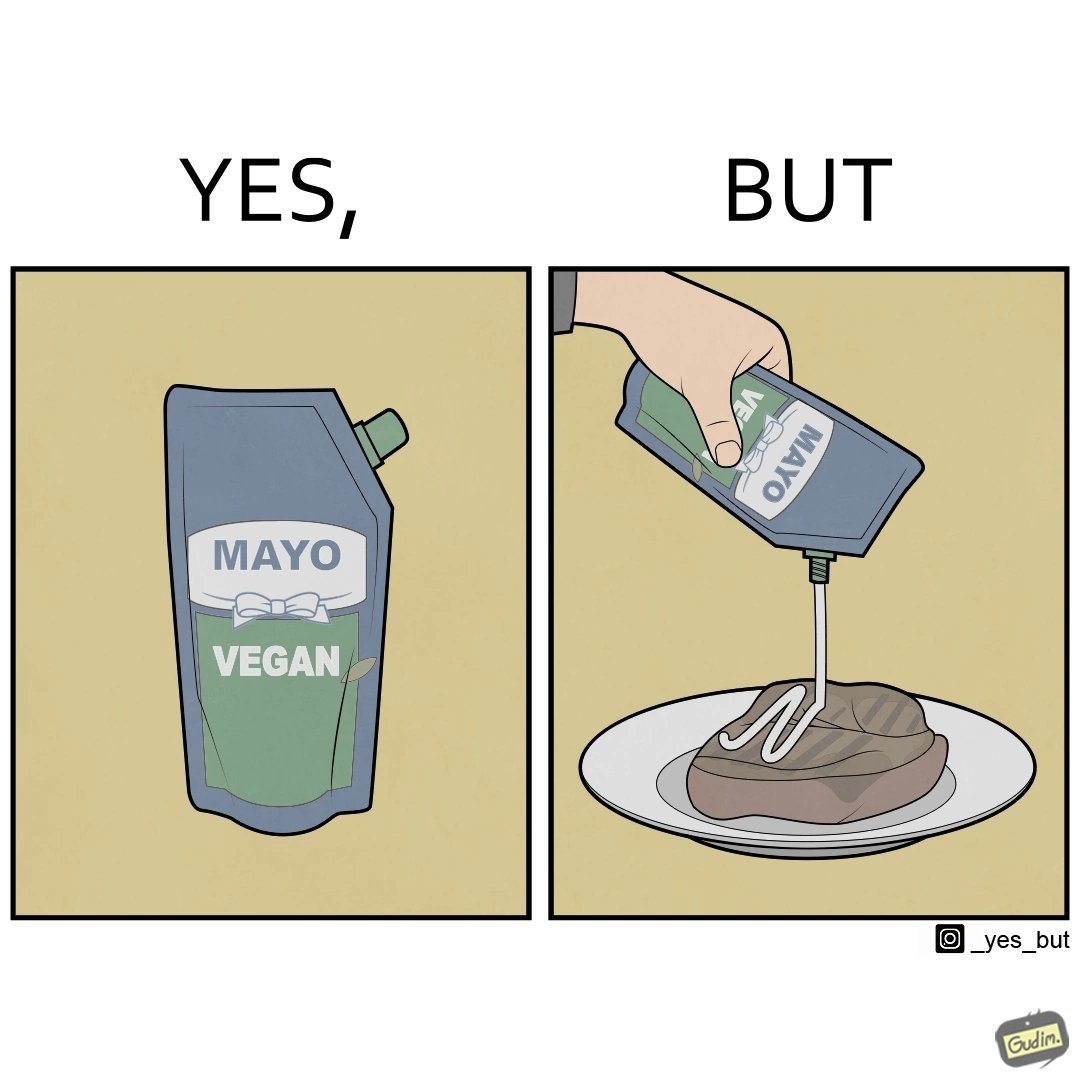Describe the contrast between the left and right parts of this image. In the left part of the image: a vegan mayo sauce packet In the right part of the image: pouring vegan mayo sauce from a packet on a rib steak 